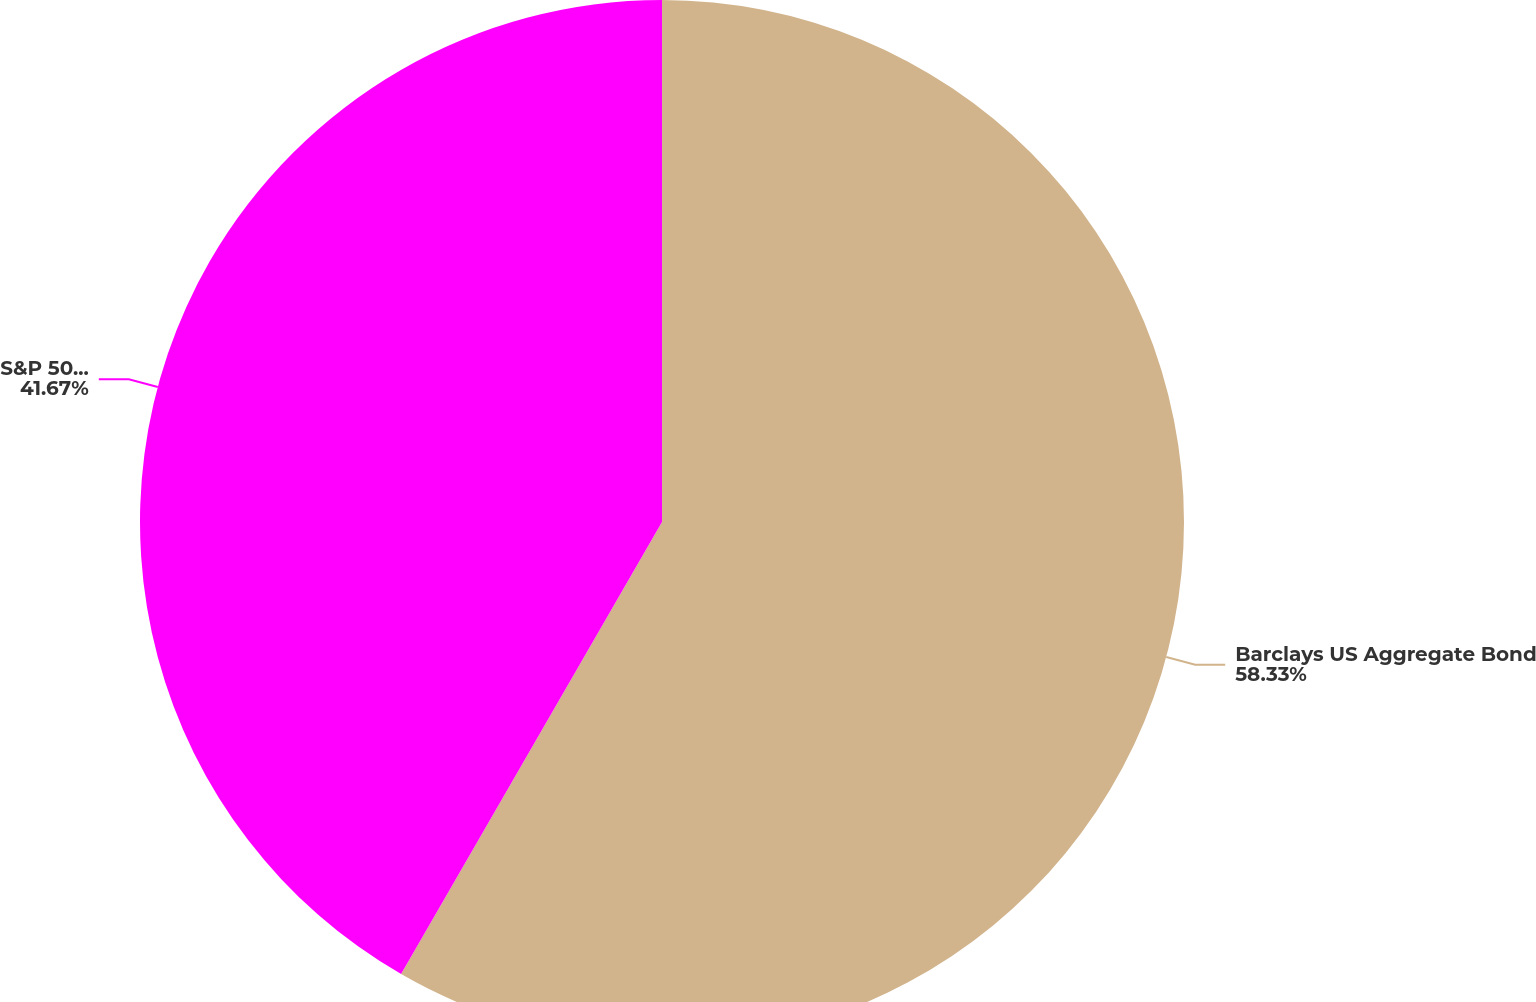Convert chart to OTSL. <chart><loc_0><loc_0><loc_500><loc_500><pie_chart><fcel>Barclays US Aggregate Bond<fcel>S&P 500 ® Index<nl><fcel>58.33%<fcel>41.67%<nl></chart> 